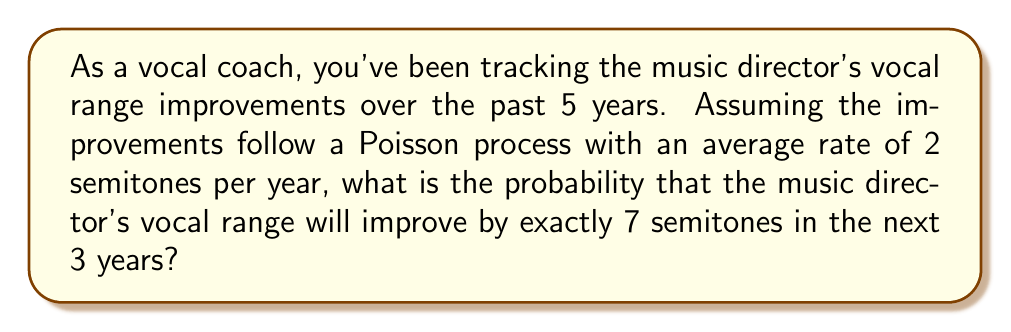What is the answer to this math problem? Let's approach this step-by-step:

1) We're dealing with a Poisson process, where:
   - The rate (λ) is 2 semitones per year
   - The time period (t) is 3 years
   - We're interested in exactly 7 improvements (k = 7)

2) For a Poisson process, the probability of k events occurring in time t is given by the formula:

   $$P(X = k) = \frac{e^{-\lambda t}(\lambda t)^k}{k!}$$

3) We need to calculate λt:
   $$\lambda t = 2 \text{ semitones/year} \times 3 \text{ years} = 6 \text{ semitones}$$

4) Now, let's substitute our values into the formula:

   $$P(X = 7) = \frac{e^{-6}(6)^7}{7!}$$

5) Let's calculate this step-by-step:
   - $e^{-6} \approx 0.00248$
   - $6^7 = 279936$
   - $7! = 5040$

6) Substituting these values:

   $$P(X = 7) = \frac{0.00248 \times 279936}{5040} \approx 0.1375$$

7) Therefore, the probability is approximately 0.1375 or 13.75%.
Answer: 0.1375 